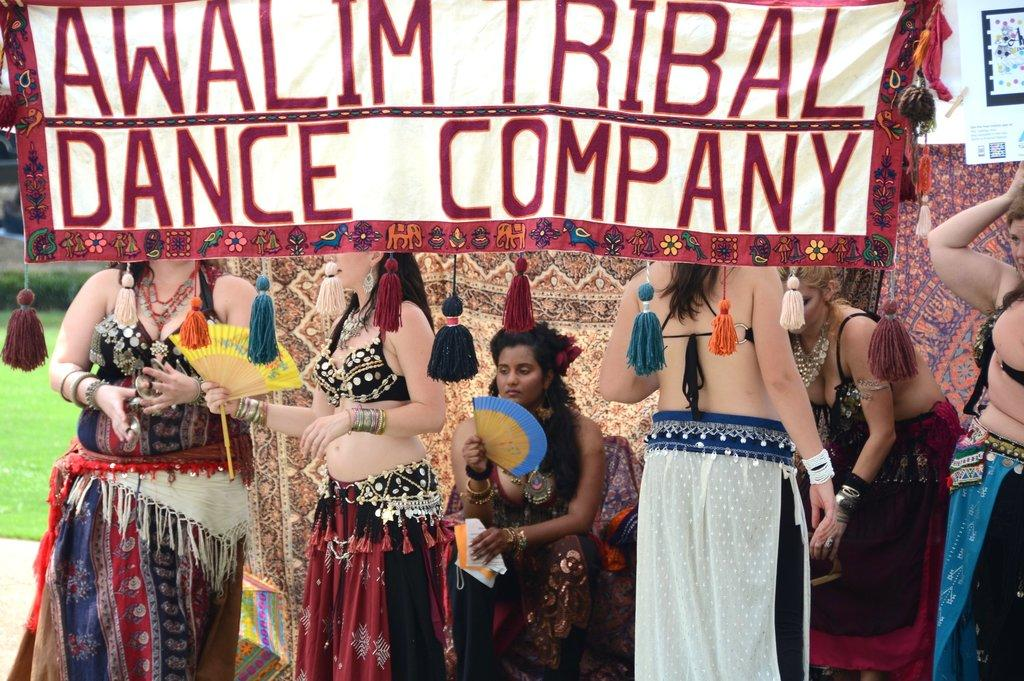Who is present in the image? There are girls in the image. What are the girls wearing? The girls are wearing costumes. What can be seen at the top of the image? There is a flex at the top side of the image. What type of environment is visible in the background? There is grassland in the background of the image. What type of corn is being harvested by the minister in the image? There is no minister or corn present in the image. How low are the girls sitting in the image? The girls are not sitting in the image; they are standing. 